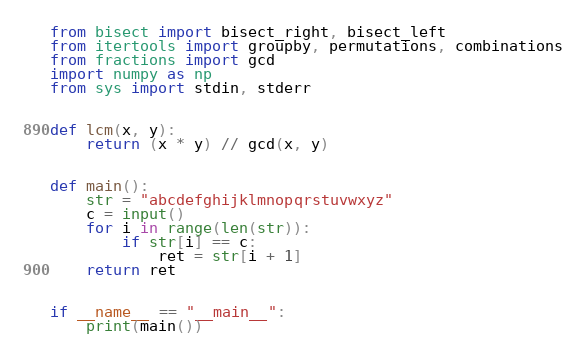Convert code to text. <code><loc_0><loc_0><loc_500><loc_500><_Python_>from bisect import bisect_right, bisect_left
from itertools import groupby, permutations, combinations
from fractions import gcd
import numpy as np
from sys import stdin, stderr


def lcm(x, y):
    return (x * y) // gcd(x, y)


def main():
    str = "abcdefghijklmnopqrstuvwxyz"
    c = input()
    for i in range(len(str)):
        if str[i] == c:
            ret = str[i + 1]
    return ret


if __name__ == "__main__":
    print(main())</code> 